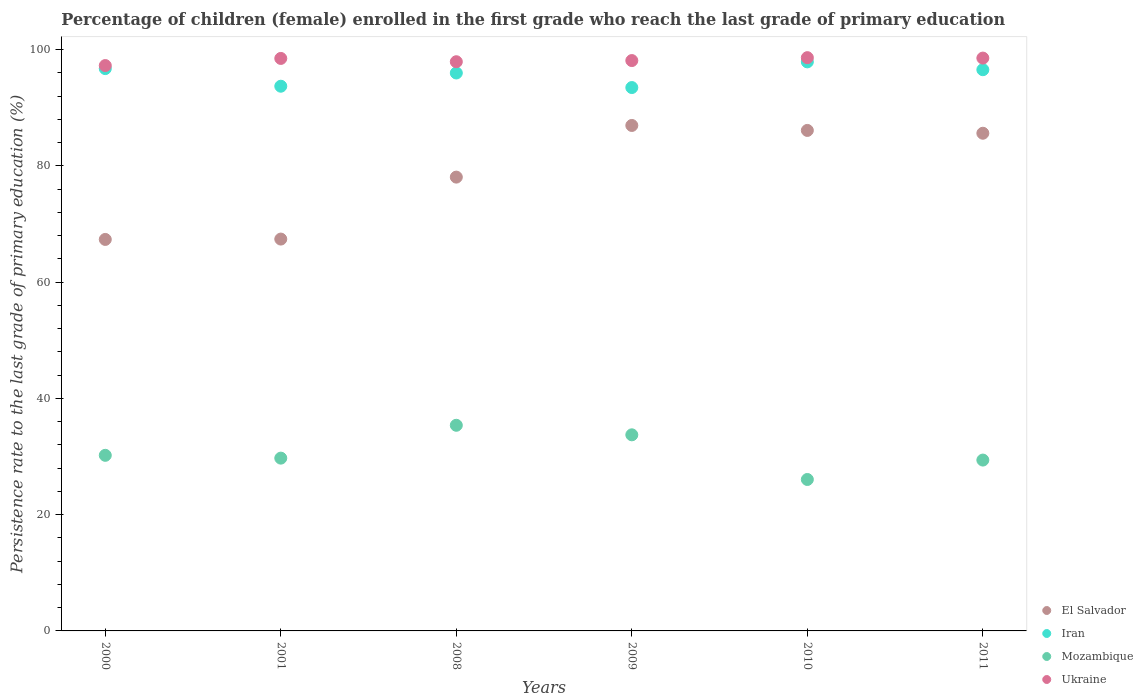How many different coloured dotlines are there?
Give a very brief answer. 4. Is the number of dotlines equal to the number of legend labels?
Your response must be concise. Yes. What is the persistence rate of children in El Salvador in 2009?
Give a very brief answer. 86.96. Across all years, what is the maximum persistence rate of children in Iran?
Provide a succinct answer. 97.9. Across all years, what is the minimum persistence rate of children in Iran?
Offer a terse response. 93.49. In which year was the persistence rate of children in El Salvador minimum?
Make the answer very short. 2000. What is the total persistence rate of children in Ukraine in the graph?
Offer a terse response. 588.99. What is the difference between the persistence rate of children in Iran in 2001 and that in 2010?
Your answer should be compact. -4.19. What is the difference between the persistence rate of children in Ukraine in 2011 and the persistence rate of children in El Salvador in 2008?
Offer a terse response. 20.48. What is the average persistence rate of children in Ukraine per year?
Offer a very short reply. 98.17. In the year 2009, what is the difference between the persistence rate of children in Iran and persistence rate of children in Ukraine?
Offer a very short reply. -4.64. In how many years, is the persistence rate of children in El Salvador greater than 60 %?
Offer a terse response. 6. What is the ratio of the persistence rate of children in Iran in 2000 to that in 2011?
Your answer should be compact. 1. Is the difference between the persistence rate of children in Iran in 2009 and 2011 greater than the difference between the persistence rate of children in Ukraine in 2009 and 2011?
Provide a succinct answer. No. What is the difference between the highest and the second highest persistence rate of children in Mozambique?
Provide a short and direct response. 1.64. What is the difference between the highest and the lowest persistence rate of children in Mozambique?
Your answer should be compact. 9.33. Is the sum of the persistence rate of children in Mozambique in 2010 and 2011 greater than the maximum persistence rate of children in Ukraine across all years?
Provide a short and direct response. No. Is it the case that in every year, the sum of the persistence rate of children in Mozambique and persistence rate of children in Ukraine  is greater than the sum of persistence rate of children in El Salvador and persistence rate of children in Iran?
Offer a very short reply. No. Is it the case that in every year, the sum of the persistence rate of children in Iran and persistence rate of children in Ukraine  is greater than the persistence rate of children in El Salvador?
Ensure brevity in your answer.  Yes. Does the persistence rate of children in Ukraine monotonically increase over the years?
Your answer should be very brief. No. How many dotlines are there?
Your response must be concise. 4. What is the difference between two consecutive major ticks on the Y-axis?
Make the answer very short. 20. Does the graph contain any zero values?
Ensure brevity in your answer.  No. Does the graph contain grids?
Provide a short and direct response. No. How many legend labels are there?
Your answer should be compact. 4. How are the legend labels stacked?
Offer a very short reply. Vertical. What is the title of the graph?
Keep it short and to the point. Percentage of children (female) enrolled in the first grade who reach the last grade of primary education. Does "Uruguay" appear as one of the legend labels in the graph?
Your answer should be compact. No. What is the label or title of the X-axis?
Your answer should be compact. Years. What is the label or title of the Y-axis?
Your answer should be very brief. Persistence rate to the last grade of primary education (%). What is the Persistence rate to the last grade of primary education (%) in El Salvador in 2000?
Your answer should be very brief. 67.35. What is the Persistence rate to the last grade of primary education (%) of Iran in 2000?
Ensure brevity in your answer.  96.74. What is the Persistence rate to the last grade of primary education (%) of Mozambique in 2000?
Ensure brevity in your answer.  30.21. What is the Persistence rate to the last grade of primary education (%) of Ukraine in 2000?
Provide a short and direct response. 97.27. What is the Persistence rate to the last grade of primary education (%) of El Salvador in 2001?
Your response must be concise. 67.42. What is the Persistence rate to the last grade of primary education (%) in Iran in 2001?
Your answer should be compact. 93.71. What is the Persistence rate to the last grade of primary education (%) in Mozambique in 2001?
Your answer should be compact. 29.73. What is the Persistence rate to the last grade of primary education (%) of Ukraine in 2001?
Make the answer very short. 98.49. What is the Persistence rate to the last grade of primary education (%) of El Salvador in 2008?
Make the answer very short. 78.08. What is the Persistence rate to the last grade of primary education (%) in Iran in 2008?
Ensure brevity in your answer.  95.99. What is the Persistence rate to the last grade of primary education (%) of Mozambique in 2008?
Offer a terse response. 35.38. What is the Persistence rate to the last grade of primary education (%) in Ukraine in 2008?
Your answer should be very brief. 97.93. What is the Persistence rate to the last grade of primary education (%) of El Salvador in 2009?
Keep it short and to the point. 86.96. What is the Persistence rate to the last grade of primary education (%) of Iran in 2009?
Provide a succinct answer. 93.49. What is the Persistence rate to the last grade of primary education (%) in Mozambique in 2009?
Provide a short and direct response. 33.74. What is the Persistence rate to the last grade of primary education (%) of Ukraine in 2009?
Your answer should be very brief. 98.13. What is the Persistence rate to the last grade of primary education (%) in El Salvador in 2010?
Offer a very short reply. 86.11. What is the Persistence rate to the last grade of primary education (%) in Iran in 2010?
Provide a succinct answer. 97.9. What is the Persistence rate to the last grade of primary education (%) of Mozambique in 2010?
Keep it short and to the point. 26.05. What is the Persistence rate to the last grade of primary education (%) in Ukraine in 2010?
Provide a short and direct response. 98.63. What is the Persistence rate to the last grade of primary education (%) in El Salvador in 2011?
Ensure brevity in your answer.  85.62. What is the Persistence rate to the last grade of primary education (%) in Iran in 2011?
Your answer should be compact. 96.55. What is the Persistence rate to the last grade of primary education (%) of Mozambique in 2011?
Ensure brevity in your answer.  29.39. What is the Persistence rate to the last grade of primary education (%) in Ukraine in 2011?
Offer a very short reply. 98.55. Across all years, what is the maximum Persistence rate to the last grade of primary education (%) of El Salvador?
Ensure brevity in your answer.  86.96. Across all years, what is the maximum Persistence rate to the last grade of primary education (%) of Iran?
Provide a succinct answer. 97.9. Across all years, what is the maximum Persistence rate to the last grade of primary education (%) of Mozambique?
Offer a very short reply. 35.38. Across all years, what is the maximum Persistence rate to the last grade of primary education (%) of Ukraine?
Your answer should be compact. 98.63. Across all years, what is the minimum Persistence rate to the last grade of primary education (%) in El Salvador?
Provide a short and direct response. 67.35. Across all years, what is the minimum Persistence rate to the last grade of primary education (%) of Iran?
Give a very brief answer. 93.49. Across all years, what is the minimum Persistence rate to the last grade of primary education (%) in Mozambique?
Give a very brief answer. 26.05. Across all years, what is the minimum Persistence rate to the last grade of primary education (%) in Ukraine?
Your response must be concise. 97.27. What is the total Persistence rate to the last grade of primary education (%) in El Salvador in the graph?
Offer a very short reply. 471.54. What is the total Persistence rate to the last grade of primary education (%) in Iran in the graph?
Keep it short and to the point. 574.39. What is the total Persistence rate to the last grade of primary education (%) of Mozambique in the graph?
Ensure brevity in your answer.  184.5. What is the total Persistence rate to the last grade of primary education (%) of Ukraine in the graph?
Offer a terse response. 588.99. What is the difference between the Persistence rate to the last grade of primary education (%) of El Salvador in 2000 and that in 2001?
Give a very brief answer. -0.06. What is the difference between the Persistence rate to the last grade of primary education (%) in Iran in 2000 and that in 2001?
Offer a very short reply. 3.03. What is the difference between the Persistence rate to the last grade of primary education (%) of Mozambique in 2000 and that in 2001?
Ensure brevity in your answer.  0.48. What is the difference between the Persistence rate to the last grade of primary education (%) in Ukraine in 2000 and that in 2001?
Keep it short and to the point. -1.23. What is the difference between the Persistence rate to the last grade of primary education (%) of El Salvador in 2000 and that in 2008?
Your response must be concise. -10.72. What is the difference between the Persistence rate to the last grade of primary education (%) in Iran in 2000 and that in 2008?
Your response must be concise. 0.76. What is the difference between the Persistence rate to the last grade of primary education (%) of Mozambique in 2000 and that in 2008?
Your answer should be very brief. -5.17. What is the difference between the Persistence rate to the last grade of primary education (%) in Ukraine in 2000 and that in 2008?
Make the answer very short. -0.66. What is the difference between the Persistence rate to the last grade of primary education (%) of El Salvador in 2000 and that in 2009?
Provide a short and direct response. -19.61. What is the difference between the Persistence rate to the last grade of primary education (%) of Iran in 2000 and that in 2009?
Give a very brief answer. 3.26. What is the difference between the Persistence rate to the last grade of primary education (%) in Mozambique in 2000 and that in 2009?
Offer a very short reply. -3.53. What is the difference between the Persistence rate to the last grade of primary education (%) in Ukraine in 2000 and that in 2009?
Offer a very short reply. -0.86. What is the difference between the Persistence rate to the last grade of primary education (%) in El Salvador in 2000 and that in 2010?
Provide a short and direct response. -18.75. What is the difference between the Persistence rate to the last grade of primary education (%) in Iran in 2000 and that in 2010?
Keep it short and to the point. -1.16. What is the difference between the Persistence rate to the last grade of primary education (%) of Mozambique in 2000 and that in 2010?
Your response must be concise. 4.16. What is the difference between the Persistence rate to the last grade of primary education (%) of Ukraine in 2000 and that in 2010?
Offer a terse response. -1.36. What is the difference between the Persistence rate to the last grade of primary education (%) in El Salvador in 2000 and that in 2011?
Make the answer very short. -18.27. What is the difference between the Persistence rate to the last grade of primary education (%) in Iran in 2000 and that in 2011?
Your answer should be compact. 0.19. What is the difference between the Persistence rate to the last grade of primary education (%) of Mozambique in 2000 and that in 2011?
Provide a succinct answer. 0.82. What is the difference between the Persistence rate to the last grade of primary education (%) of Ukraine in 2000 and that in 2011?
Give a very brief answer. -1.29. What is the difference between the Persistence rate to the last grade of primary education (%) in El Salvador in 2001 and that in 2008?
Give a very brief answer. -10.66. What is the difference between the Persistence rate to the last grade of primary education (%) of Iran in 2001 and that in 2008?
Keep it short and to the point. -2.28. What is the difference between the Persistence rate to the last grade of primary education (%) in Mozambique in 2001 and that in 2008?
Make the answer very short. -5.65. What is the difference between the Persistence rate to the last grade of primary education (%) in Ukraine in 2001 and that in 2008?
Offer a very short reply. 0.57. What is the difference between the Persistence rate to the last grade of primary education (%) in El Salvador in 2001 and that in 2009?
Make the answer very short. -19.55. What is the difference between the Persistence rate to the last grade of primary education (%) of Iran in 2001 and that in 2009?
Ensure brevity in your answer.  0.23. What is the difference between the Persistence rate to the last grade of primary education (%) of Mozambique in 2001 and that in 2009?
Your answer should be compact. -4.01. What is the difference between the Persistence rate to the last grade of primary education (%) in Ukraine in 2001 and that in 2009?
Give a very brief answer. 0.37. What is the difference between the Persistence rate to the last grade of primary education (%) of El Salvador in 2001 and that in 2010?
Keep it short and to the point. -18.69. What is the difference between the Persistence rate to the last grade of primary education (%) of Iran in 2001 and that in 2010?
Give a very brief answer. -4.19. What is the difference between the Persistence rate to the last grade of primary education (%) of Mozambique in 2001 and that in 2010?
Give a very brief answer. 3.67. What is the difference between the Persistence rate to the last grade of primary education (%) in Ukraine in 2001 and that in 2010?
Your answer should be compact. -0.13. What is the difference between the Persistence rate to the last grade of primary education (%) of El Salvador in 2001 and that in 2011?
Your response must be concise. -18.21. What is the difference between the Persistence rate to the last grade of primary education (%) of Iran in 2001 and that in 2011?
Your answer should be compact. -2.84. What is the difference between the Persistence rate to the last grade of primary education (%) in Mozambique in 2001 and that in 2011?
Your answer should be compact. 0.33. What is the difference between the Persistence rate to the last grade of primary education (%) of Ukraine in 2001 and that in 2011?
Give a very brief answer. -0.06. What is the difference between the Persistence rate to the last grade of primary education (%) of El Salvador in 2008 and that in 2009?
Ensure brevity in your answer.  -8.89. What is the difference between the Persistence rate to the last grade of primary education (%) in Iran in 2008 and that in 2009?
Ensure brevity in your answer.  2.5. What is the difference between the Persistence rate to the last grade of primary education (%) in Mozambique in 2008 and that in 2009?
Your answer should be compact. 1.64. What is the difference between the Persistence rate to the last grade of primary education (%) in Ukraine in 2008 and that in 2009?
Provide a succinct answer. -0.2. What is the difference between the Persistence rate to the last grade of primary education (%) of El Salvador in 2008 and that in 2010?
Your answer should be very brief. -8.03. What is the difference between the Persistence rate to the last grade of primary education (%) in Iran in 2008 and that in 2010?
Offer a very short reply. -1.91. What is the difference between the Persistence rate to the last grade of primary education (%) of Mozambique in 2008 and that in 2010?
Keep it short and to the point. 9.33. What is the difference between the Persistence rate to the last grade of primary education (%) of Ukraine in 2008 and that in 2010?
Your answer should be compact. -0.7. What is the difference between the Persistence rate to the last grade of primary education (%) in El Salvador in 2008 and that in 2011?
Your answer should be very brief. -7.55. What is the difference between the Persistence rate to the last grade of primary education (%) of Iran in 2008 and that in 2011?
Provide a succinct answer. -0.56. What is the difference between the Persistence rate to the last grade of primary education (%) in Mozambique in 2008 and that in 2011?
Offer a very short reply. 5.98. What is the difference between the Persistence rate to the last grade of primary education (%) in Ukraine in 2008 and that in 2011?
Provide a short and direct response. -0.63. What is the difference between the Persistence rate to the last grade of primary education (%) in El Salvador in 2009 and that in 2010?
Offer a terse response. 0.85. What is the difference between the Persistence rate to the last grade of primary education (%) in Iran in 2009 and that in 2010?
Your answer should be very brief. -4.42. What is the difference between the Persistence rate to the last grade of primary education (%) in Mozambique in 2009 and that in 2010?
Offer a terse response. 7.68. What is the difference between the Persistence rate to the last grade of primary education (%) in Ukraine in 2009 and that in 2010?
Your answer should be very brief. -0.5. What is the difference between the Persistence rate to the last grade of primary education (%) in El Salvador in 2009 and that in 2011?
Provide a succinct answer. 1.34. What is the difference between the Persistence rate to the last grade of primary education (%) of Iran in 2009 and that in 2011?
Your answer should be compact. -3.07. What is the difference between the Persistence rate to the last grade of primary education (%) in Mozambique in 2009 and that in 2011?
Offer a terse response. 4.34. What is the difference between the Persistence rate to the last grade of primary education (%) of Ukraine in 2009 and that in 2011?
Give a very brief answer. -0.43. What is the difference between the Persistence rate to the last grade of primary education (%) of El Salvador in 2010 and that in 2011?
Make the answer very short. 0.49. What is the difference between the Persistence rate to the last grade of primary education (%) of Iran in 2010 and that in 2011?
Give a very brief answer. 1.35. What is the difference between the Persistence rate to the last grade of primary education (%) in Mozambique in 2010 and that in 2011?
Your answer should be compact. -3.34. What is the difference between the Persistence rate to the last grade of primary education (%) of Ukraine in 2010 and that in 2011?
Keep it short and to the point. 0.07. What is the difference between the Persistence rate to the last grade of primary education (%) of El Salvador in 2000 and the Persistence rate to the last grade of primary education (%) of Iran in 2001?
Your answer should be very brief. -26.36. What is the difference between the Persistence rate to the last grade of primary education (%) of El Salvador in 2000 and the Persistence rate to the last grade of primary education (%) of Mozambique in 2001?
Offer a terse response. 37.63. What is the difference between the Persistence rate to the last grade of primary education (%) in El Salvador in 2000 and the Persistence rate to the last grade of primary education (%) in Ukraine in 2001?
Your response must be concise. -31.14. What is the difference between the Persistence rate to the last grade of primary education (%) in Iran in 2000 and the Persistence rate to the last grade of primary education (%) in Mozambique in 2001?
Give a very brief answer. 67.02. What is the difference between the Persistence rate to the last grade of primary education (%) of Iran in 2000 and the Persistence rate to the last grade of primary education (%) of Ukraine in 2001?
Give a very brief answer. -1.75. What is the difference between the Persistence rate to the last grade of primary education (%) in Mozambique in 2000 and the Persistence rate to the last grade of primary education (%) in Ukraine in 2001?
Give a very brief answer. -68.28. What is the difference between the Persistence rate to the last grade of primary education (%) of El Salvador in 2000 and the Persistence rate to the last grade of primary education (%) of Iran in 2008?
Keep it short and to the point. -28.64. What is the difference between the Persistence rate to the last grade of primary education (%) of El Salvador in 2000 and the Persistence rate to the last grade of primary education (%) of Mozambique in 2008?
Your answer should be compact. 31.97. What is the difference between the Persistence rate to the last grade of primary education (%) of El Salvador in 2000 and the Persistence rate to the last grade of primary education (%) of Ukraine in 2008?
Offer a very short reply. -30.57. What is the difference between the Persistence rate to the last grade of primary education (%) in Iran in 2000 and the Persistence rate to the last grade of primary education (%) in Mozambique in 2008?
Your response must be concise. 61.37. What is the difference between the Persistence rate to the last grade of primary education (%) of Iran in 2000 and the Persistence rate to the last grade of primary education (%) of Ukraine in 2008?
Your response must be concise. -1.18. What is the difference between the Persistence rate to the last grade of primary education (%) in Mozambique in 2000 and the Persistence rate to the last grade of primary education (%) in Ukraine in 2008?
Your answer should be compact. -67.72. What is the difference between the Persistence rate to the last grade of primary education (%) of El Salvador in 2000 and the Persistence rate to the last grade of primary education (%) of Iran in 2009?
Give a very brief answer. -26.13. What is the difference between the Persistence rate to the last grade of primary education (%) of El Salvador in 2000 and the Persistence rate to the last grade of primary education (%) of Mozambique in 2009?
Make the answer very short. 33.62. What is the difference between the Persistence rate to the last grade of primary education (%) of El Salvador in 2000 and the Persistence rate to the last grade of primary education (%) of Ukraine in 2009?
Your answer should be compact. -30.77. What is the difference between the Persistence rate to the last grade of primary education (%) of Iran in 2000 and the Persistence rate to the last grade of primary education (%) of Mozambique in 2009?
Offer a terse response. 63.01. What is the difference between the Persistence rate to the last grade of primary education (%) of Iran in 2000 and the Persistence rate to the last grade of primary education (%) of Ukraine in 2009?
Your response must be concise. -1.38. What is the difference between the Persistence rate to the last grade of primary education (%) in Mozambique in 2000 and the Persistence rate to the last grade of primary education (%) in Ukraine in 2009?
Your response must be concise. -67.92. What is the difference between the Persistence rate to the last grade of primary education (%) in El Salvador in 2000 and the Persistence rate to the last grade of primary education (%) in Iran in 2010?
Provide a short and direct response. -30.55. What is the difference between the Persistence rate to the last grade of primary education (%) in El Salvador in 2000 and the Persistence rate to the last grade of primary education (%) in Mozambique in 2010?
Provide a succinct answer. 41.3. What is the difference between the Persistence rate to the last grade of primary education (%) in El Salvador in 2000 and the Persistence rate to the last grade of primary education (%) in Ukraine in 2010?
Offer a very short reply. -31.27. What is the difference between the Persistence rate to the last grade of primary education (%) of Iran in 2000 and the Persistence rate to the last grade of primary education (%) of Mozambique in 2010?
Make the answer very short. 70.69. What is the difference between the Persistence rate to the last grade of primary education (%) of Iran in 2000 and the Persistence rate to the last grade of primary education (%) of Ukraine in 2010?
Keep it short and to the point. -1.88. What is the difference between the Persistence rate to the last grade of primary education (%) in Mozambique in 2000 and the Persistence rate to the last grade of primary education (%) in Ukraine in 2010?
Your answer should be compact. -68.42. What is the difference between the Persistence rate to the last grade of primary education (%) in El Salvador in 2000 and the Persistence rate to the last grade of primary education (%) in Iran in 2011?
Your answer should be compact. -29.2. What is the difference between the Persistence rate to the last grade of primary education (%) in El Salvador in 2000 and the Persistence rate to the last grade of primary education (%) in Mozambique in 2011?
Offer a terse response. 37.96. What is the difference between the Persistence rate to the last grade of primary education (%) in El Salvador in 2000 and the Persistence rate to the last grade of primary education (%) in Ukraine in 2011?
Your response must be concise. -31.2. What is the difference between the Persistence rate to the last grade of primary education (%) of Iran in 2000 and the Persistence rate to the last grade of primary education (%) of Mozambique in 2011?
Your answer should be very brief. 67.35. What is the difference between the Persistence rate to the last grade of primary education (%) in Iran in 2000 and the Persistence rate to the last grade of primary education (%) in Ukraine in 2011?
Provide a short and direct response. -1.81. What is the difference between the Persistence rate to the last grade of primary education (%) in Mozambique in 2000 and the Persistence rate to the last grade of primary education (%) in Ukraine in 2011?
Provide a short and direct response. -68.34. What is the difference between the Persistence rate to the last grade of primary education (%) of El Salvador in 2001 and the Persistence rate to the last grade of primary education (%) of Iran in 2008?
Provide a short and direct response. -28.57. What is the difference between the Persistence rate to the last grade of primary education (%) in El Salvador in 2001 and the Persistence rate to the last grade of primary education (%) in Mozambique in 2008?
Make the answer very short. 32.04. What is the difference between the Persistence rate to the last grade of primary education (%) in El Salvador in 2001 and the Persistence rate to the last grade of primary education (%) in Ukraine in 2008?
Provide a succinct answer. -30.51. What is the difference between the Persistence rate to the last grade of primary education (%) of Iran in 2001 and the Persistence rate to the last grade of primary education (%) of Mozambique in 2008?
Offer a terse response. 58.33. What is the difference between the Persistence rate to the last grade of primary education (%) of Iran in 2001 and the Persistence rate to the last grade of primary education (%) of Ukraine in 2008?
Your answer should be very brief. -4.21. What is the difference between the Persistence rate to the last grade of primary education (%) in Mozambique in 2001 and the Persistence rate to the last grade of primary education (%) in Ukraine in 2008?
Ensure brevity in your answer.  -68.2. What is the difference between the Persistence rate to the last grade of primary education (%) in El Salvador in 2001 and the Persistence rate to the last grade of primary education (%) in Iran in 2009?
Provide a short and direct response. -26.07. What is the difference between the Persistence rate to the last grade of primary education (%) of El Salvador in 2001 and the Persistence rate to the last grade of primary education (%) of Mozambique in 2009?
Provide a succinct answer. 33.68. What is the difference between the Persistence rate to the last grade of primary education (%) in El Salvador in 2001 and the Persistence rate to the last grade of primary education (%) in Ukraine in 2009?
Offer a very short reply. -30.71. What is the difference between the Persistence rate to the last grade of primary education (%) in Iran in 2001 and the Persistence rate to the last grade of primary education (%) in Mozambique in 2009?
Offer a terse response. 59.98. What is the difference between the Persistence rate to the last grade of primary education (%) of Iran in 2001 and the Persistence rate to the last grade of primary education (%) of Ukraine in 2009?
Provide a succinct answer. -4.41. What is the difference between the Persistence rate to the last grade of primary education (%) of Mozambique in 2001 and the Persistence rate to the last grade of primary education (%) of Ukraine in 2009?
Your response must be concise. -68.4. What is the difference between the Persistence rate to the last grade of primary education (%) in El Salvador in 2001 and the Persistence rate to the last grade of primary education (%) in Iran in 2010?
Give a very brief answer. -30.49. What is the difference between the Persistence rate to the last grade of primary education (%) in El Salvador in 2001 and the Persistence rate to the last grade of primary education (%) in Mozambique in 2010?
Provide a succinct answer. 41.36. What is the difference between the Persistence rate to the last grade of primary education (%) of El Salvador in 2001 and the Persistence rate to the last grade of primary education (%) of Ukraine in 2010?
Keep it short and to the point. -31.21. What is the difference between the Persistence rate to the last grade of primary education (%) of Iran in 2001 and the Persistence rate to the last grade of primary education (%) of Mozambique in 2010?
Give a very brief answer. 67.66. What is the difference between the Persistence rate to the last grade of primary education (%) in Iran in 2001 and the Persistence rate to the last grade of primary education (%) in Ukraine in 2010?
Provide a short and direct response. -4.91. What is the difference between the Persistence rate to the last grade of primary education (%) in Mozambique in 2001 and the Persistence rate to the last grade of primary education (%) in Ukraine in 2010?
Your answer should be very brief. -68.9. What is the difference between the Persistence rate to the last grade of primary education (%) in El Salvador in 2001 and the Persistence rate to the last grade of primary education (%) in Iran in 2011?
Ensure brevity in your answer.  -29.14. What is the difference between the Persistence rate to the last grade of primary education (%) of El Salvador in 2001 and the Persistence rate to the last grade of primary education (%) of Mozambique in 2011?
Ensure brevity in your answer.  38.02. What is the difference between the Persistence rate to the last grade of primary education (%) of El Salvador in 2001 and the Persistence rate to the last grade of primary education (%) of Ukraine in 2011?
Your answer should be compact. -31.14. What is the difference between the Persistence rate to the last grade of primary education (%) of Iran in 2001 and the Persistence rate to the last grade of primary education (%) of Mozambique in 2011?
Your answer should be compact. 64.32. What is the difference between the Persistence rate to the last grade of primary education (%) in Iran in 2001 and the Persistence rate to the last grade of primary education (%) in Ukraine in 2011?
Offer a terse response. -4.84. What is the difference between the Persistence rate to the last grade of primary education (%) in Mozambique in 2001 and the Persistence rate to the last grade of primary education (%) in Ukraine in 2011?
Offer a terse response. -68.83. What is the difference between the Persistence rate to the last grade of primary education (%) of El Salvador in 2008 and the Persistence rate to the last grade of primary education (%) of Iran in 2009?
Your answer should be very brief. -15.41. What is the difference between the Persistence rate to the last grade of primary education (%) in El Salvador in 2008 and the Persistence rate to the last grade of primary education (%) in Mozambique in 2009?
Provide a short and direct response. 44.34. What is the difference between the Persistence rate to the last grade of primary education (%) of El Salvador in 2008 and the Persistence rate to the last grade of primary education (%) of Ukraine in 2009?
Give a very brief answer. -20.05. What is the difference between the Persistence rate to the last grade of primary education (%) of Iran in 2008 and the Persistence rate to the last grade of primary education (%) of Mozambique in 2009?
Provide a succinct answer. 62.25. What is the difference between the Persistence rate to the last grade of primary education (%) of Iran in 2008 and the Persistence rate to the last grade of primary education (%) of Ukraine in 2009?
Provide a short and direct response. -2.14. What is the difference between the Persistence rate to the last grade of primary education (%) of Mozambique in 2008 and the Persistence rate to the last grade of primary education (%) of Ukraine in 2009?
Offer a terse response. -62.75. What is the difference between the Persistence rate to the last grade of primary education (%) in El Salvador in 2008 and the Persistence rate to the last grade of primary education (%) in Iran in 2010?
Your answer should be very brief. -19.83. What is the difference between the Persistence rate to the last grade of primary education (%) of El Salvador in 2008 and the Persistence rate to the last grade of primary education (%) of Mozambique in 2010?
Provide a short and direct response. 52.02. What is the difference between the Persistence rate to the last grade of primary education (%) in El Salvador in 2008 and the Persistence rate to the last grade of primary education (%) in Ukraine in 2010?
Provide a short and direct response. -20.55. What is the difference between the Persistence rate to the last grade of primary education (%) in Iran in 2008 and the Persistence rate to the last grade of primary education (%) in Mozambique in 2010?
Provide a succinct answer. 69.93. What is the difference between the Persistence rate to the last grade of primary education (%) of Iran in 2008 and the Persistence rate to the last grade of primary education (%) of Ukraine in 2010?
Offer a terse response. -2.64. What is the difference between the Persistence rate to the last grade of primary education (%) of Mozambique in 2008 and the Persistence rate to the last grade of primary education (%) of Ukraine in 2010?
Make the answer very short. -63.25. What is the difference between the Persistence rate to the last grade of primary education (%) in El Salvador in 2008 and the Persistence rate to the last grade of primary education (%) in Iran in 2011?
Offer a terse response. -18.48. What is the difference between the Persistence rate to the last grade of primary education (%) of El Salvador in 2008 and the Persistence rate to the last grade of primary education (%) of Mozambique in 2011?
Keep it short and to the point. 48.68. What is the difference between the Persistence rate to the last grade of primary education (%) in El Salvador in 2008 and the Persistence rate to the last grade of primary education (%) in Ukraine in 2011?
Your answer should be very brief. -20.48. What is the difference between the Persistence rate to the last grade of primary education (%) of Iran in 2008 and the Persistence rate to the last grade of primary education (%) of Mozambique in 2011?
Provide a succinct answer. 66.59. What is the difference between the Persistence rate to the last grade of primary education (%) in Iran in 2008 and the Persistence rate to the last grade of primary education (%) in Ukraine in 2011?
Provide a short and direct response. -2.56. What is the difference between the Persistence rate to the last grade of primary education (%) in Mozambique in 2008 and the Persistence rate to the last grade of primary education (%) in Ukraine in 2011?
Your response must be concise. -63.17. What is the difference between the Persistence rate to the last grade of primary education (%) in El Salvador in 2009 and the Persistence rate to the last grade of primary education (%) in Iran in 2010?
Make the answer very short. -10.94. What is the difference between the Persistence rate to the last grade of primary education (%) of El Salvador in 2009 and the Persistence rate to the last grade of primary education (%) of Mozambique in 2010?
Make the answer very short. 60.91. What is the difference between the Persistence rate to the last grade of primary education (%) in El Salvador in 2009 and the Persistence rate to the last grade of primary education (%) in Ukraine in 2010?
Give a very brief answer. -11.66. What is the difference between the Persistence rate to the last grade of primary education (%) in Iran in 2009 and the Persistence rate to the last grade of primary education (%) in Mozambique in 2010?
Offer a terse response. 67.43. What is the difference between the Persistence rate to the last grade of primary education (%) of Iran in 2009 and the Persistence rate to the last grade of primary education (%) of Ukraine in 2010?
Ensure brevity in your answer.  -5.14. What is the difference between the Persistence rate to the last grade of primary education (%) of Mozambique in 2009 and the Persistence rate to the last grade of primary education (%) of Ukraine in 2010?
Your answer should be very brief. -64.89. What is the difference between the Persistence rate to the last grade of primary education (%) in El Salvador in 2009 and the Persistence rate to the last grade of primary education (%) in Iran in 2011?
Offer a very short reply. -9.59. What is the difference between the Persistence rate to the last grade of primary education (%) in El Salvador in 2009 and the Persistence rate to the last grade of primary education (%) in Mozambique in 2011?
Keep it short and to the point. 57.57. What is the difference between the Persistence rate to the last grade of primary education (%) in El Salvador in 2009 and the Persistence rate to the last grade of primary education (%) in Ukraine in 2011?
Provide a short and direct response. -11.59. What is the difference between the Persistence rate to the last grade of primary education (%) of Iran in 2009 and the Persistence rate to the last grade of primary education (%) of Mozambique in 2011?
Make the answer very short. 64.09. What is the difference between the Persistence rate to the last grade of primary education (%) of Iran in 2009 and the Persistence rate to the last grade of primary education (%) of Ukraine in 2011?
Give a very brief answer. -5.07. What is the difference between the Persistence rate to the last grade of primary education (%) of Mozambique in 2009 and the Persistence rate to the last grade of primary education (%) of Ukraine in 2011?
Provide a succinct answer. -64.81. What is the difference between the Persistence rate to the last grade of primary education (%) of El Salvador in 2010 and the Persistence rate to the last grade of primary education (%) of Iran in 2011?
Offer a terse response. -10.45. What is the difference between the Persistence rate to the last grade of primary education (%) of El Salvador in 2010 and the Persistence rate to the last grade of primary education (%) of Mozambique in 2011?
Give a very brief answer. 56.71. What is the difference between the Persistence rate to the last grade of primary education (%) in El Salvador in 2010 and the Persistence rate to the last grade of primary education (%) in Ukraine in 2011?
Your answer should be compact. -12.45. What is the difference between the Persistence rate to the last grade of primary education (%) of Iran in 2010 and the Persistence rate to the last grade of primary education (%) of Mozambique in 2011?
Make the answer very short. 68.51. What is the difference between the Persistence rate to the last grade of primary education (%) of Iran in 2010 and the Persistence rate to the last grade of primary education (%) of Ukraine in 2011?
Offer a terse response. -0.65. What is the difference between the Persistence rate to the last grade of primary education (%) in Mozambique in 2010 and the Persistence rate to the last grade of primary education (%) in Ukraine in 2011?
Ensure brevity in your answer.  -72.5. What is the average Persistence rate to the last grade of primary education (%) in El Salvador per year?
Provide a succinct answer. 78.59. What is the average Persistence rate to the last grade of primary education (%) of Iran per year?
Your answer should be compact. 95.73. What is the average Persistence rate to the last grade of primary education (%) in Mozambique per year?
Your answer should be compact. 30.75. What is the average Persistence rate to the last grade of primary education (%) in Ukraine per year?
Your response must be concise. 98.17. In the year 2000, what is the difference between the Persistence rate to the last grade of primary education (%) in El Salvador and Persistence rate to the last grade of primary education (%) in Iran?
Make the answer very short. -29.39. In the year 2000, what is the difference between the Persistence rate to the last grade of primary education (%) of El Salvador and Persistence rate to the last grade of primary education (%) of Mozambique?
Provide a short and direct response. 37.14. In the year 2000, what is the difference between the Persistence rate to the last grade of primary education (%) of El Salvador and Persistence rate to the last grade of primary education (%) of Ukraine?
Give a very brief answer. -29.91. In the year 2000, what is the difference between the Persistence rate to the last grade of primary education (%) in Iran and Persistence rate to the last grade of primary education (%) in Mozambique?
Provide a succinct answer. 66.53. In the year 2000, what is the difference between the Persistence rate to the last grade of primary education (%) of Iran and Persistence rate to the last grade of primary education (%) of Ukraine?
Offer a terse response. -0.52. In the year 2000, what is the difference between the Persistence rate to the last grade of primary education (%) of Mozambique and Persistence rate to the last grade of primary education (%) of Ukraine?
Provide a short and direct response. -67.06. In the year 2001, what is the difference between the Persistence rate to the last grade of primary education (%) of El Salvador and Persistence rate to the last grade of primary education (%) of Iran?
Keep it short and to the point. -26.3. In the year 2001, what is the difference between the Persistence rate to the last grade of primary education (%) of El Salvador and Persistence rate to the last grade of primary education (%) of Mozambique?
Give a very brief answer. 37.69. In the year 2001, what is the difference between the Persistence rate to the last grade of primary education (%) of El Salvador and Persistence rate to the last grade of primary education (%) of Ukraine?
Offer a very short reply. -31.08. In the year 2001, what is the difference between the Persistence rate to the last grade of primary education (%) in Iran and Persistence rate to the last grade of primary education (%) in Mozambique?
Your answer should be compact. 63.99. In the year 2001, what is the difference between the Persistence rate to the last grade of primary education (%) of Iran and Persistence rate to the last grade of primary education (%) of Ukraine?
Your response must be concise. -4.78. In the year 2001, what is the difference between the Persistence rate to the last grade of primary education (%) of Mozambique and Persistence rate to the last grade of primary education (%) of Ukraine?
Offer a terse response. -68.77. In the year 2008, what is the difference between the Persistence rate to the last grade of primary education (%) of El Salvador and Persistence rate to the last grade of primary education (%) of Iran?
Your response must be concise. -17.91. In the year 2008, what is the difference between the Persistence rate to the last grade of primary education (%) in El Salvador and Persistence rate to the last grade of primary education (%) in Mozambique?
Keep it short and to the point. 42.7. In the year 2008, what is the difference between the Persistence rate to the last grade of primary education (%) in El Salvador and Persistence rate to the last grade of primary education (%) in Ukraine?
Provide a short and direct response. -19.85. In the year 2008, what is the difference between the Persistence rate to the last grade of primary education (%) of Iran and Persistence rate to the last grade of primary education (%) of Mozambique?
Offer a terse response. 60.61. In the year 2008, what is the difference between the Persistence rate to the last grade of primary education (%) in Iran and Persistence rate to the last grade of primary education (%) in Ukraine?
Offer a terse response. -1.94. In the year 2008, what is the difference between the Persistence rate to the last grade of primary education (%) of Mozambique and Persistence rate to the last grade of primary education (%) of Ukraine?
Provide a short and direct response. -62.55. In the year 2009, what is the difference between the Persistence rate to the last grade of primary education (%) in El Salvador and Persistence rate to the last grade of primary education (%) in Iran?
Offer a very short reply. -6.52. In the year 2009, what is the difference between the Persistence rate to the last grade of primary education (%) in El Salvador and Persistence rate to the last grade of primary education (%) in Mozambique?
Offer a terse response. 53.22. In the year 2009, what is the difference between the Persistence rate to the last grade of primary education (%) in El Salvador and Persistence rate to the last grade of primary education (%) in Ukraine?
Provide a succinct answer. -11.16. In the year 2009, what is the difference between the Persistence rate to the last grade of primary education (%) of Iran and Persistence rate to the last grade of primary education (%) of Mozambique?
Offer a very short reply. 59.75. In the year 2009, what is the difference between the Persistence rate to the last grade of primary education (%) in Iran and Persistence rate to the last grade of primary education (%) in Ukraine?
Provide a short and direct response. -4.64. In the year 2009, what is the difference between the Persistence rate to the last grade of primary education (%) in Mozambique and Persistence rate to the last grade of primary education (%) in Ukraine?
Make the answer very short. -64.39. In the year 2010, what is the difference between the Persistence rate to the last grade of primary education (%) of El Salvador and Persistence rate to the last grade of primary education (%) of Iran?
Provide a succinct answer. -11.79. In the year 2010, what is the difference between the Persistence rate to the last grade of primary education (%) of El Salvador and Persistence rate to the last grade of primary education (%) of Mozambique?
Offer a very short reply. 60.05. In the year 2010, what is the difference between the Persistence rate to the last grade of primary education (%) of El Salvador and Persistence rate to the last grade of primary education (%) of Ukraine?
Your response must be concise. -12.52. In the year 2010, what is the difference between the Persistence rate to the last grade of primary education (%) of Iran and Persistence rate to the last grade of primary education (%) of Mozambique?
Provide a succinct answer. 71.85. In the year 2010, what is the difference between the Persistence rate to the last grade of primary education (%) in Iran and Persistence rate to the last grade of primary education (%) in Ukraine?
Offer a terse response. -0.72. In the year 2010, what is the difference between the Persistence rate to the last grade of primary education (%) of Mozambique and Persistence rate to the last grade of primary education (%) of Ukraine?
Your answer should be compact. -72.57. In the year 2011, what is the difference between the Persistence rate to the last grade of primary education (%) in El Salvador and Persistence rate to the last grade of primary education (%) in Iran?
Your answer should be very brief. -10.93. In the year 2011, what is the difference between the Persistence rate to the last grade of primary education (%) of El Salvador and Persistence rate to the last grade of primary education (%) of Mozambique?
Ensure brevity in your answer.  56.23. In the year 2011, what is the difference between the Persistence rate to the last grade of primary education (%) of El Salvador and Persistence rate to the last grade of primary education (%) of Ukraine?
Ensure brevity in your answer.  -12.93. In the year 2011, what is the difference between the Persistence rate to the last grade of primary education (%) of Iran and Persistence rate to the last grade of primary education (%) of Mozambique?
Provide a short and direct response. 67.16. In the year 2011, what is the difference between the Persistence rate to the last grade of primary education (%) of Iran and Persistence rate to the last grade of primary education (%) of Ukraine?
Offer a very short reply. -2. In the year 2011, what is the difference between the Persistence rate to the last grade of primary education (%) of Mozambique and Persistence rate to the last grade of primary education (%) of Ukraine?
Ensure brevity in your answer.  -69.16. What is the ratio of the Persistence rate to the last grade of primary education (%) of Iran in 2000 to that in 2001?
Ensure brevity in your answer.  1.03. What is the ratio of the Persistence rate to the last grade of primary education (%) in Mozambique in 2000 to that in 2001?
Your answer should be compact. 1.02. What is the ratio of the Persistence rate to the last grade of primary education (%) in Ukraine in 2000 to that in 2001?
Offer a very short reply. 0.99. What is the ratio of the Persistence rate to the last grade of primary education (%) in El Salvador in 2000 to that in 2008?
Ensure brevity in your answer.  0.86. What is the ratio of the Persistence rate to the last grade of primary education (%) of Iran in 2000 to that in 2008?
Ensure brevity in your answer.  1.01. What is the ratio of the Persistence rate to the last grade of primary education (%) of Mozambique in 2000 to that in 2008?
Make the answer very short. 0.85. What is the ratio of the Persistence rate to the last grade of primary education (%) of Ukraine in 2000 to that in 2008?
Provide a succinct answer. 0.99. What is the ratio of the Persistence rate to the last grade of primary education (%) in El Salvador in 2000 to that in 2009?
Offer a terse response. 0.77. What is the ratio of the Persistence rate to the last grade of primary education (%) of Iran in 2000 to that in 2009?
Make the answer very short. 1.03. What is the ratio of the Persistence rate to the last grade of primary education (%) in Mozambique in 2000 to that in 2009?
Your response must be concise. 0.9. What is the ratio of the Persistence rate to the last grade of primary education (%) in Ukraine in 2000 to that in 2009?
Offer a terse response. 0.99. What is the ratio of the Persistence rate to the last grade of primary education (%) of El Salvador in 2000 to that in 2010?
Ensure brevity in your answer.  0.78. What is the ratio of the Persistence rate to the last grade of primary education (%) of Iran in 2000 to that in 2010?
Your answer should be compact. 0.99. What is the ratio of the Persistence rate to the last grade of primary education (%) of Mozambique in 2000 to that in 2010?
Make the answer very short. 1.16. What is the ratio of the Persistence rate to the last grade of primary education (%) in Ukraine in 2000 to that in 2010?
Your answer should be very brief. 0.99. What is the ratio of the Persistence rate to the last grade of primary education (%) in El Salvador in 2000 to that in 2011?
Give a very brief answer. 0.79. What is the ratio of the Persistence rate to the last grade of primary education (%) in Mozambique in 2000 to that in 2011?
Offer a very short reply. 1.03. What is the ratio of the Persistence rate to the last grade of primary education (%) of Ukraine in 2000 to that in 2011?
Give a very brief answer. 0.99. What is the ratio of the Persistence rate to the last grade of primary education (%) in El Salvador in 2001 to that in 2008?
Provide a succinct answer. 0.86. What is the ratio of the Persistence rate to the last grade of primary education (%) of Iran in 2001 to that in 2008?
Provide a succinct answer. 0.98. What is the ratio of the Persistence rate to the last grade of primary education (%) of Mozambique in 2001 to that in 2008?
Your answer should be very brief. 0.84. What is the ratio of the Persistence rate to the last grade of primary education (%) of El Salvador in 2001 to that in 2009?
Provide a short and direct response. 0.78. What is the ratio of the Persistence rate to the last grade of primary education (%) of Iran in 2001 to that in 2009?
Your answer should be compact. 1. What is the ratio of the Persistence rate to the last grade of primary education (%) of Mozambique in 2001 to that in 2009?
Give a very brief answer. 0.88. What is the ratio of the Persistence rate to the last grade of primary education (%) in El Salvador in 2001 to that in 2010?
Your answer should be compact. 0.78. What is the ratio of the Persistence rate to the last grade of primary education (%) of Iran in 2001 to that in 2010?
Offer a very short reply. 0.96. What is the ratio of the Persistence rate to the last grade of primary education (%) in Mozambique in 2001 to that in 2010?
Offer a very short reply. 1.14. What is the ratio of the Persistence rate to the last grade of primary education (%) in El Salvador in 2001 to that in 2011?
Ensure brevity in your answer.  0.79. What is the ratio of the Persistence rate to the last grade of primary education (%) in Iran in 2001 to that in 2011?
Make the answer very short. 0.97. What is the ratio of the Persistence rate to the last grade of primary education (%) of Mozambique in 2001 to that in 2011?
Your answer should be very brief. 1.01. What is the ratio of the Persistence rate to the last grade of primary education (%) of Ukraine in 2001 to that in 2011?
Your answer should be very brief. 1. What is the ratio of the Persistence rate to the last grade of primary education (%) in El Salvador in 2008 to that in 2009?
Your answer should be compact. 0.9. What is the ratio of the Persistence rate to the last grade of primary education (%) in Iran in 2008 to that in 2009?
Your answer should be very brief. 1.03. What is the ratio of the Persistence rate to the last grade of primary education (%) in Mozambique in 2008 to that in 2009?
Provide a succinct answer. 1.05. What is the ratio of the Persistence rate to the last grade of primary education (%) in El Salvador in 2008 to that in 2010?
Provide a short and direct response. 0.91. What is the ratio of the Persistence rate to the last grade of primary education (%) of Iran in 2008 to that in 2010?
Your answer should be compact. 0.98. What is the ratio of the Persistence rate to the last grade of primary education (%) in Mozambique in 2008 to that in 2010?
Your answer should be compact. 1.36. What is the ratio of the Persistence rate to the last grade of primary education (%) in Ukraine in 2008 to that in 2010?
Your answer should be very brief. 0.99. What is the ratio of the Persistence rate to the last grade of primary education (%) in El Salvador in 2008 to that in 2011?
Your answer should be very brief. 0.91. What is the ratio of the Persistence rate to the last grade of primary education (%) of Iran in 2008 to that in 2011?
Offer a very short reply. 0.99. What is the ratio of the Persistence rate to the last grade of primary education (%) of Mozambique in 2008 to that in 2011?
Your answer should be very brief. 1.2. What is the ratio of the Persistence rate to the last grade of primary education (%) of Ukraine in 2008 to that in 2011?
Your answer should be compact. 0.99. What is the ratio of the Persistence rate to the last grade of primary education (%) of El Salvador in 2009 to that in 2010?
Offer a terse response. 1.01. What is the ratio of the Persistence rate to the last grade of primary education (%) of Iran in 2009 to that in 2010?
Keep it short and to the point. 0.95. What is the ratio of the Persistence rate to the last grade of primary education (%) in Mozambique in 2009 to that in 2010?
Your response must be concise. 1.29. What is the ratio of the Persistence rate to the last grade of primary education (%) in El Salvador in 2009 to that in 2011?
Ensure brevity in your answer.  1.02. What is the ratio of the Persistence rate to the last grade of primary education (%) of Iran in 2009 to that in 2011?
Keep it short and to the point. 0.97. What is the ratio of the Persistence rate to the last grade of primary education (%) of Mozambique in 2009 to that in 2011?
Provide a short and direct response. 1.15. What is the ratio of the Persistence rate to the last grade of primary education (%) of Ukraine in 2009 to that in 2011?
Make the answer very short. 1. What is the ratio of the Persistence rate to the last grade of primary education (%) in El Salvador in 2010 to that in 2011?
Provide a succinct answer. 1.01. What is the ratio of the Persistence rate to the last grade of primary education (%) of Iran in 2010 to that in 2011?
Offer a terse response. 1.01. What is the ratio of the Persistence rate to the last grade of primary education (%) of Mozambique in 2010 to that in 2011?
Ensure brevity in your answer.  0.89. What is the ratio of the Persistence rate to the last grade of primary education (%) of Ukraine in 2010 to that in 2011?
Make the answer very short. 1. What is the difference between the highest and the second highest Persistence rate to the last grade of primary education (%) of El Salvador?
Ensure brevity in your answer.  0.85. What is the difference between the highest and the second highest Persistence rate to the last grade of primary education (%) of Iran?
Your response must be concise. 1.16. What is the difference between the highest and the second highest Persistence rate to the last grade of primary education (%) of Mozambique?
Provide a succinct answer. 1.64. What is the difference between the highest and the second highest Persistence rate to the last grade of primary education (%) of Ukraine?
Offer a terse response. 0.07. What is the difference between the highest and the lowest Persistence rate to the last grade of primary education (%) in El Salvador?
Make the answer very short. 19.61. What is the difference between the highest and the lowest Persistence rate to the last grade of primary education (%) of Iran?
Make the answer very short. 4.42. What is the difference between the highest and the lowest Persistence rate to the last grade of primary education (%) in Mozambique?
Offer a very short reply. 9.33. What is the difference between the highest and the lowest Persistence rate to the last grade of primary education (%) in Ukraine?
Your answer should be very brief. 1.36. 